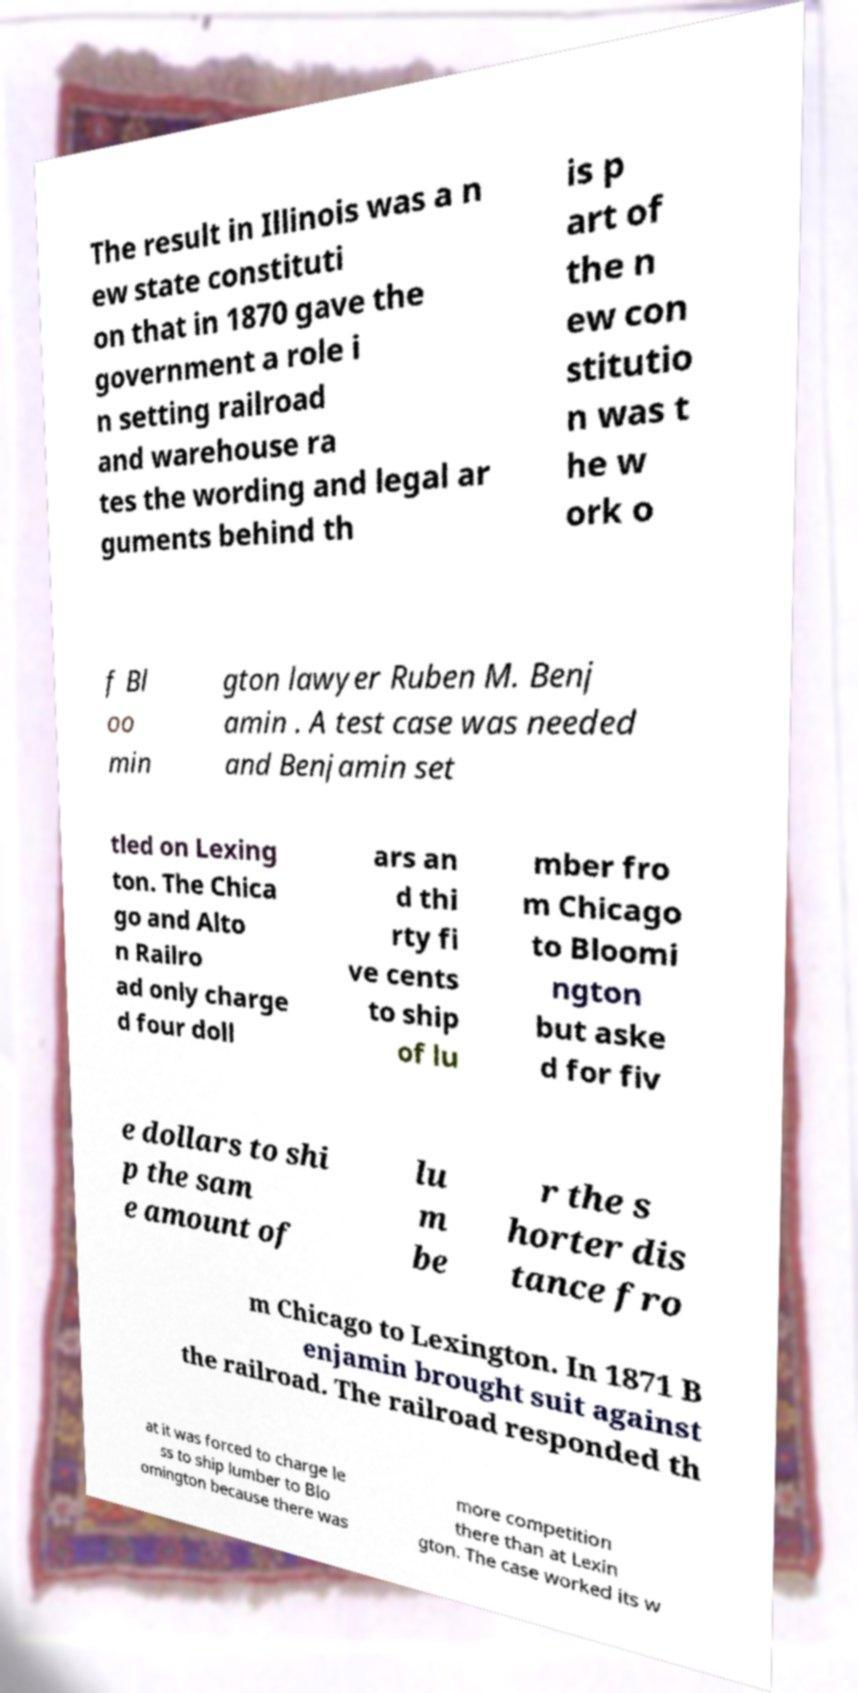Please identify and transcribe the text found in this image. The result in Illinois was a n ew state constituti on that in 1870 gave the government a role i n setting railroad and warehouse ra tes the wording and legal ar guments behind th is p art of the n ew con stitutio n was t he w ork o f Bl oo min gton lawyer Ruben M. Benj amin . A test case was needed and Benjamin set tled on Lexing ton. The Chica go and Alto n Railro ad only charge d four doll ars an d thi rty fi ve cents to ship of lu mber fro m Chicago to Bloomi ngton but aske d for fiv e dollars to shi p the sam e amount of lu m be r the s horter dis tance fro m Chicago to Lexington. In 1871 B enjamin brought suit against the railroad. The railroad responded th at it was forced to charge le ss to ship lumber to Blo omington because there was more competition there than at Lexin gton. The case worked its w 